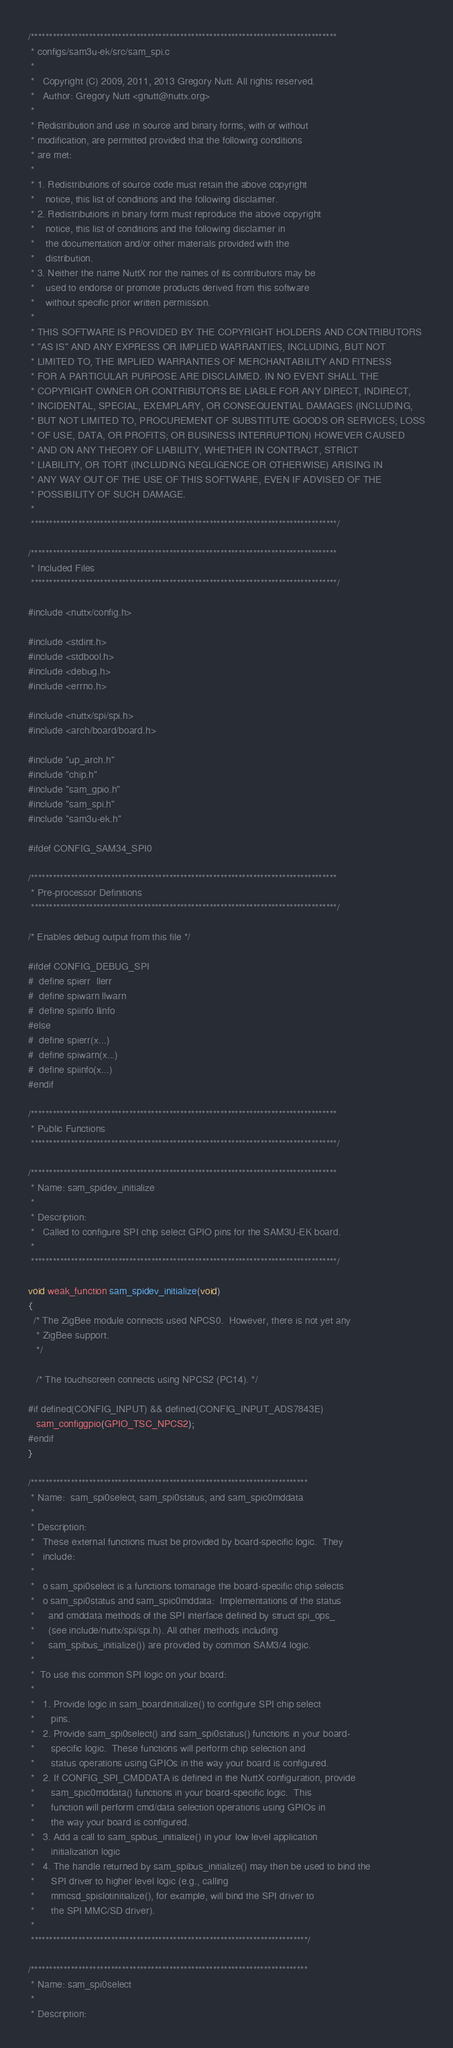<code> <loc_0><loc_0><loc_500><loc_500><_C_>/************************************************************************************
 * configs/sam3u-ek/src/sam_spi.c
 *
 *   Copyright (C) 2009, 2011, 2013 Gregory Nutt. All rights reserved.
 *   Author: Gregory Nutt <gnutt@nuttx.org>
 *
 * Redistribution and use in source and binary forms, with or without
 * modification, are permitted provided that the following conditions
 * are met:
 *
 * 1. Redistributions of source code must retain the above copyright
 *    notice, this list of conditions and the following disclaimer.
 * 2. Redistributions in binary form must reproduce the above copyright
 *    notice, this list of conditions and the following disclaimer in
 *    the documentation and/or other materials provided with the
 *    distribution.
 * 3. Neither the name NuttX nor the names of its contributors may be
 *    used to endorse or promote products derived from this software
 *    without specific prior written permission.
 *
 * THIS SOFTWARE IS PROVIDED BY THE COPYRIGHT HOLDERS AND CONTRIBUTORS
 * "AS IS" AND ANY EXPRESS OR IMPLIED WARRANTIES, INCLUDING, BUT NOT
 * LIMITED TO, THE IMPLIED WARRANTIES OF MERCHANTABILITY AND FITNESS
 * FOR A PARTICULAR PURPOSE ARE DISCLAIMED. IN NO EVENT SHALL THE
 * COPYRIGHT OWNER OR CONTRIBUTORS BE LIABLE FOR ANY DIRECT, INDIRECT,
 * INCIDENTAL, SPECIAL, EXEMPLARY, OR CONSEQUENTIAL DAMAGES (INCLUDING,
 * BUT NOT LIMITED TO, PROCUREMENT OF SUBSTITUTE GOODS OR SERVICES; LOSS
 * OF USE, DATA, OR PROFITS; OR BUSINESS INTERRUPTION) HOWEVER CAUSED
 * AND ON ANY THEORY OF LIABILITY, WHETHER IN CONTRACT, STRICT
 * LIABILITY, OR TORT (INCLUDING NEGLIGENCE OR OTHERWISE) ARISING IN
 * ANY WAY OUT OF THE USE OF THIS SOFTWARE, EVEN IF ADVISED OF THE
 * POSSIBILITY OF SUCH DAMAGE.
 *
 ************************************************************************************/

/************************************************************************************
 * Included Files
 ************************************************************************************/

#include <nuttx/config.h>

#include <stdint.h>
#include <stdbool.h>
#include <debug.h>
#include <errno.h>

#include <nuttx/spi/spi.h>
#include <arch/board/board.h>

#include "up_arch.h"
#include "chip.h"
#include "sam_gpio.h"
#include "sam_spi.h"
#include "sam3u-ek.h"

#ifdef CONFIG_SAM34_SPI0

/************************************************************************************
 * Pre-processor Definitions
 ************************************************************************************/

/* Enables debug output from this file */

#ifdef CONFIG_DEBUG_SPI
#  define spierr  llerr
#  define spiwarn llwarn
#  define spiinfo llinfo
#else
#  define spierr(x...)
#  define spiwarn(x...)
#  define spiinfo(x...)
#endif

/************************************************************************************
 * Public Functions
 ************************************************************************************/

/************************************************************************************
 * Name: sam_spidev_initialize
 *
 * Description:
 *   Called to configure SPI chip select GPIO pins for the SAM3U-EK board.
 *
 ************************************************************************************/

void weak_function sam_spidev_initialize(void)
{
  /* The ZigBee module connects used NPCS0.  However, there is not yet any
   * ZigBee support.
   */

   /* The touchscreen connects using NPCS2 (PC14). */

#if defined(CONFIG_INPUT) && defined(CONFIG_INPUT_ADS7843E)
   sam_configgpio(GPIO_TSC_NPCS2);
#endif
}

/****************************************************************************
 * Name:  sam_spi0select, sam_spi0status, and sam_spic0mddata
 *
 * Description:
 *   These external functions must be provided by board-specific logic.  They
 *   include:
 *
 *   o sam_spi0select is a functions tomanage the board-specific chip selects
 *   o sam_spi0status and sam_spic0mddata:  Implementations of the status
 *     and cmddata methods of the SPI interface defined by struct spi_ops_
 *     (see include/nuttx/spi/spi.h). All other methods including
 *     sam_spibus_initialize()) are provided by common SAM3/4 logic.
 *
 *  To use this common SPI logic on your board:
 *
 *   1. Provide logic in sam_boardinitialize() to configure SPI chip select
 *      pins.
 *   2. Provide sam_spi0select() and sam_spi0status() functions in your board-
 *      specific logic.  These functions will perform chip selection and
 *      status operations using GPIOs in the way your board is configured.
 *   2. If CONFIG_SPI_CMDDATA is defined in the NuttX configuration, provide
 *      sam_spic0mddata() functions in your board-specific logic.  This
 *      function will perform cmd/data selection operations using GPIOs in
 *      the way your board is configured.
 *   3. Add a call to sam_spibus_initialize() in your low level application
 *      initialization logic
 *   4. The handle returned by sam_spibus_initialize() may then be used to bind the
 *      SPI driver to higher level logic (e.g., calling
 *      mmcsd_spislotinitialize(), for example, will bind the SPI driver to
 *      the SPI MMC/SD driver).
 *
 ****************************************************************************/

/****************************************************************************
 * Name: sam_spi0select
 *
 * Description:</code> 